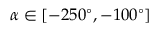Convert formula to latex. <formula><loc_0><loc_0><loc_500><loc_500>\alpha \in [ - 2 5 0 ^ { \circ } , - 1 0 0 ^ { \circ } ]</formula> 